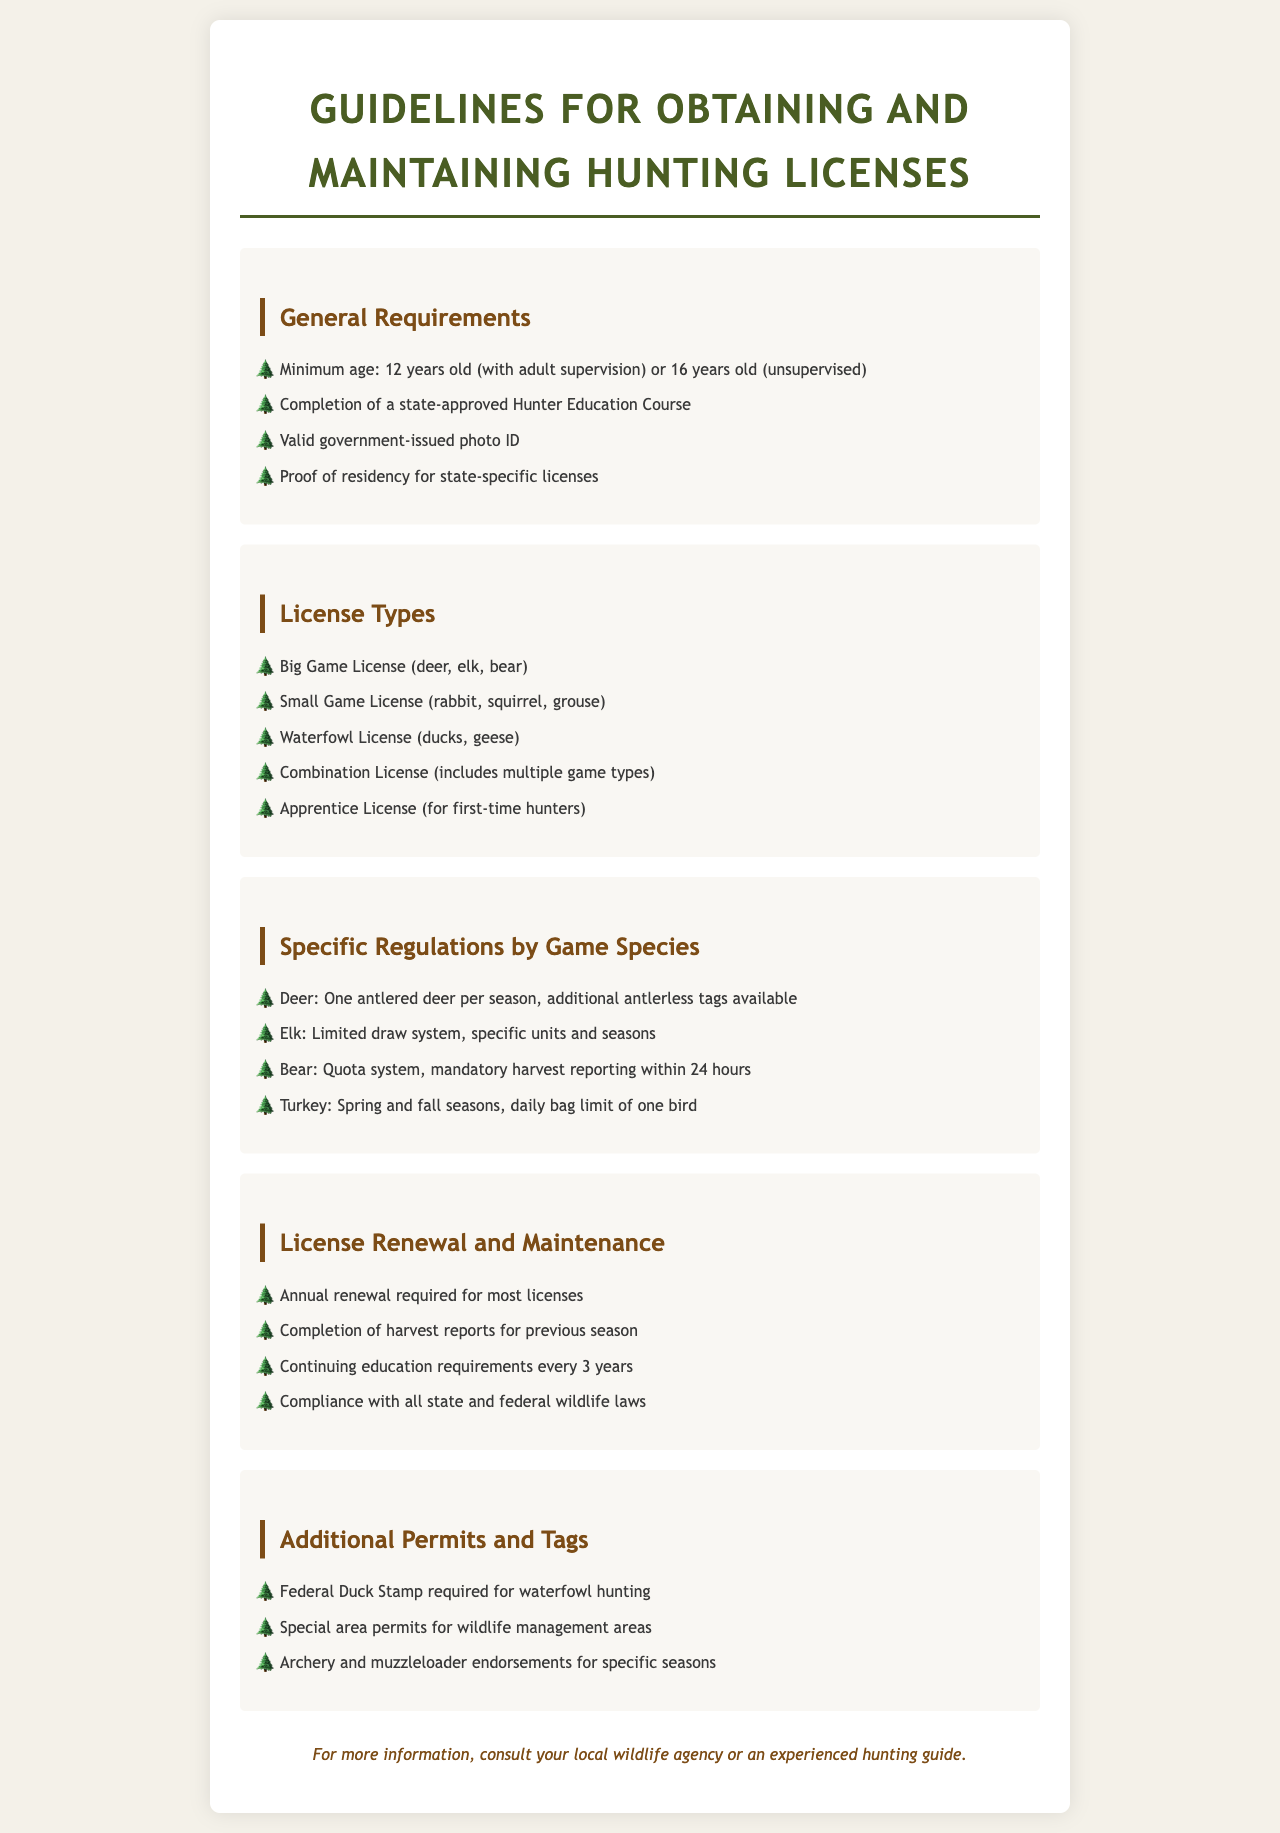What is the minimum age for a hunting license with adult supervision? The document states that the minimum age is 12 years old with adult supervision.
Answer: 12 years old What course must be completed to obtain a hunting license? The document mentions the requirement to complete a state-approved Hunter Education Course.
Answer: Hunter Education Course How many big game species are listed in the license types? The document lists three specific big game species: deer, elk, and bear.
Answer: Three What is the daily bag limit for turkey? The document states that the daily bag limit for turkey is one bird.
Answer: One bird What is required for waterfowl hunting in addition to a license? According to the document, a Federal Duck Stamp is required for waterfowl hunting.
Answer: Federal Duck Stamp What is the required renewal frequency for most licenses? The document specifies that an annual renewal is required for most licenses.
Answer: Annual What must hunters comply with to maintain their licenses? The document indicates compliance with all state and federal wildlife laws is required.
Answer: Wildlife laws What is the status of the elk hunting system mentioned? The document describes the elk hunting system as a limited draw system.
Answer: Limited draw system How often do hunters need to complete continuing education? The document states that continuing education is required every 3 years.
Answer: Every 3 years 